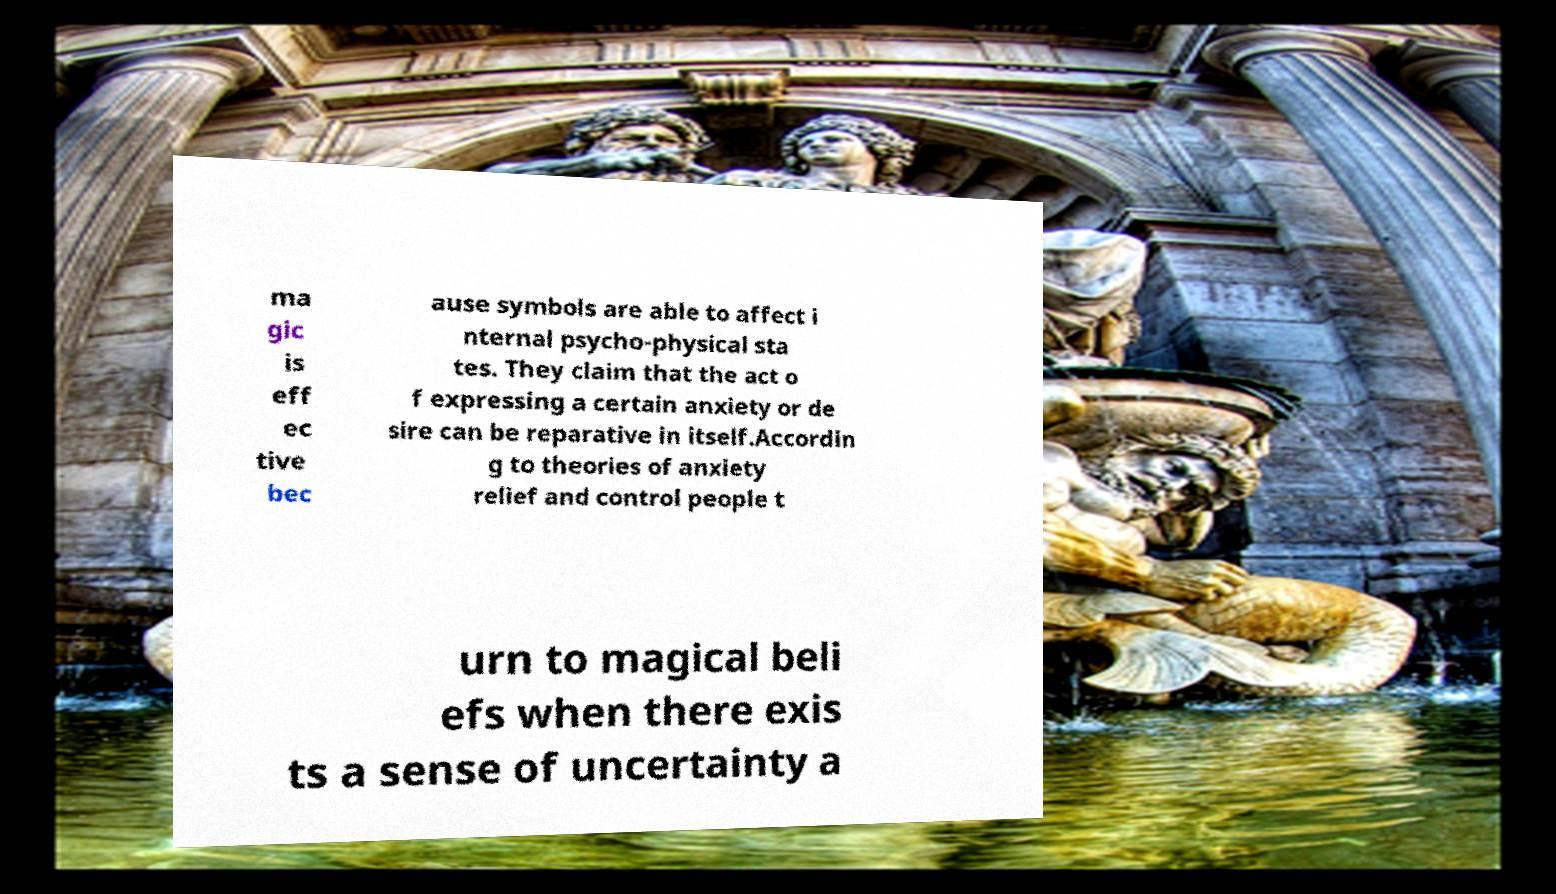What messages or text are displayed in this image? I need them in a readable, typed format. ma gic is eff ec tive bec ause symbols are able to affect i nternal psycho-physical sta tes. They claim that the act o f expressing a certain anxiety or de sire can be reparative in itself.Accordin g to theories of anxiety relief and control people t urn to magical beli efs when there exis ts a sense of uncertainty a 